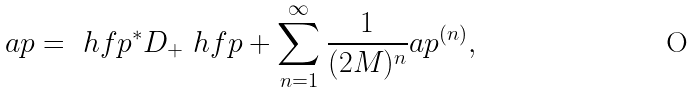Convert formula to latex. <formula><loc_0><loc_0><loc_500><loc_500>\L a p = \ h f p ^ { * } D _ { + } \ h f p + \sum _ { n = 1 } ^ { \infty } \frac { 1 } { ( 2 M ) ^ { n } } \L a p ^ { ( n ) } ,</formula> 